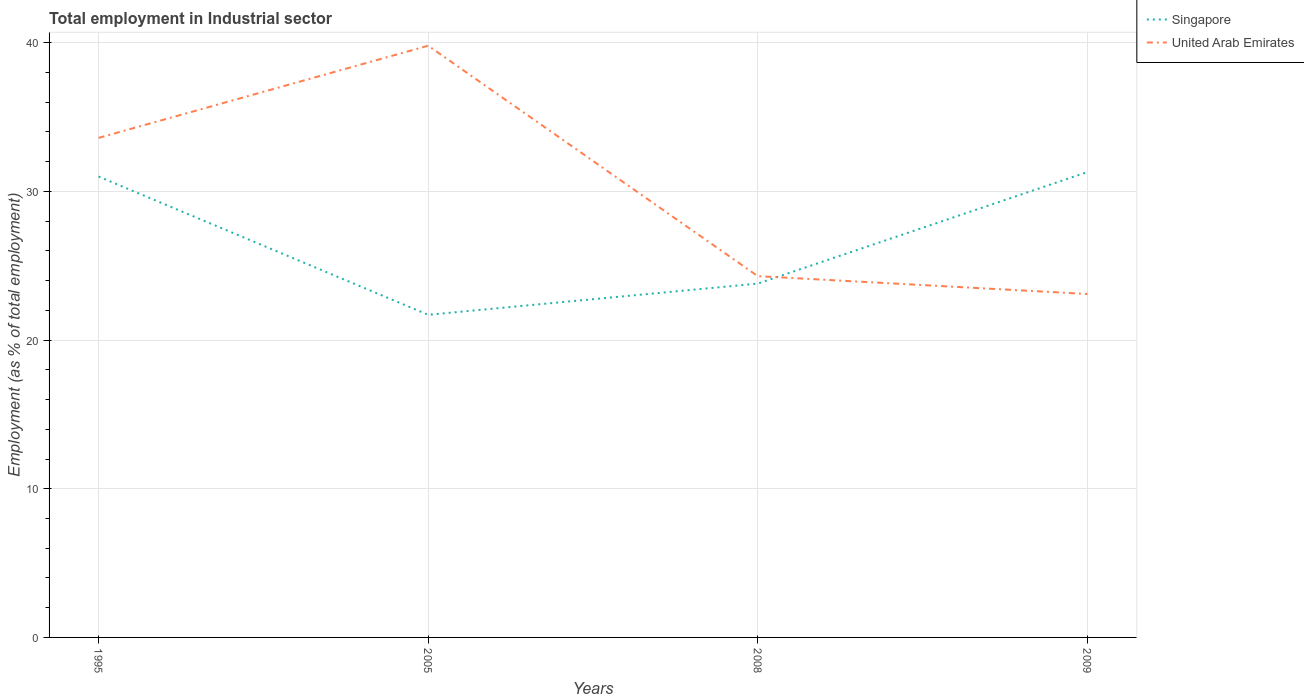Across all years, what is the maximum employment in industrial sector in United Arab Emirates?
Ensure brevity in your answer.  23.1. What is the total employment in industrial sector in United Arab Emirates in the graph?
Provide a succinct answer. 1.2. What is the difference between the highest and the second highest employment in industrial sector in Singapore?
Give a very brief answer. 9.6. What is the difference between the highest and the lowest employment in industrial sector in United Arab Emirates?
Make the answer very short. 2. Is the employment in industrial sector in Singapore strictly greater than the employment in industrial sector in United Arab Emirates over the years?
Provide a short and direct response. No. How many lines are there?
Offer a very short reply. 2. How many years are there in the graph?
Provide a short and direct response. 4. What is the difference between two consecutive major ticks on the Y-axis?
Provide a succinct answer. 10. Are the values on the major ticks of Y-axis written in scientific E-notation?
Your response must be concise. No. How many legend labels are there?
Provide a short and direct response. 2. What is the title of the graph?
Your response must be concise. Total employment in Industrial sector. Does "St. Kitts and Nevis" appear as one of the legend labels in the graph?
Your response must be concise. No. What is the label or title of the X-axis?
Make the answer very short. Years. What is the label or title of the Y-axis?
Your answer should be compact. Employment (as % of total employment). What is the Employment (as % of total employment) in Singapore in 1995?
Offer a terse response. 31. What is the Employment (as % of total employment) in United Arab Emirates in 1995?
Your answer should be compact. 33.6. What is the Employment (as % of total employment) in Singapore in 2005?
Keep it short and to the point. 21.7. What is the Employment (as % of total employment) of United Arab Emirates in 2005?
Keep it short and to the point. 39.8. What is the Employment (as % of total employment) in Singapore in 2008?
Your answer should be very brief. 23.8. What is the Employment (as % of total employment) in United Arab Emirates in 2008?
Keep it short and to the point. 24.3. What is the Employment (as % of total employment) in Singapore in 2009?
Keep it short and to the point. 31.3. What is the Employment (as % of total employment) of United Arab Emirates in 2009?
Your answer should be very brief. 23.1. Across all years, what is the maximum Employment (as % of total employment) in Singapore?
Provide a short and direct response. 31.3. Across all years, what is the maximum Employment (as % of total employment) in United Arab Emirates?
Provide a succinct answer. 39.8. Across all years, what is the minimum Employment (as % of total employment) of Singapore?
Ensure brevity in your answer.  21.7. Across all years, what is the minimum Employment (as % of total employment) of United Arab Emirates?
Provide a short and direct response. 23.1. What is the total Employment (as % of total employment) in Singapore in the graph?
Offer a very short reply. 107.8. What is the total Employment (as % of total employment) of United Arab Emirates in the graph?
Provide a short and direct response. 120.8. What is the difference between the Employment (as % of total employment) in United Arab Emirates in 1995 and that in 2005?
Offer a very short reply. -6.2. What is the difference between the Employment (as % of total employment) of Singapore in 1995 and that in 2008?
Ensure brevity in your answer.  7.2. What is the difference between the Employment (as % of total employment) of United Arab Emirates in 1995 and that in 2008?
Keep it short and to the point. 9.3. What is the difference between the Employment (as % of total employment) of Singapore in 1995 and that in 2009?
Give a very brief answer. -0.3. What is the difference between the Employment (as % of total employment) of Singapore in 2005 and that in 2008?
Offer a very short reply. -2.1. What is the difference between the Employment (as % of total employment) in United Arab Emirates in 2005 and that in 2008?
Your answer should be very brief. 15.5. What is the difference between the Employment (as % of total employment) of United Arab Emirates in 2005 and that in 2009?
Offer a very short reply. 16.7. What is the difference between the Employment (as % of total employment) in Singapore in 1995 and the Employment (as % of total employment) in United Arab Emirates in 2008?
Keep it short and to the point. 6.7. What is the difference between the Employment (as % of total employment) of Singapore in 2005 and the Employment (as % of total employment) of United Arab Emirates in 2009?
Offer a very short reply. -1.4. What is the average Employment (as % of total employment) in Singapore per year?
Keep it short and to the point. 26.95. What is the average Employment (as % of total employment) in United Arab Emirates per year?
Provide a short and direct response. 30.2. In the year 2005, what is the difference between the Employment (as % of total employment) in Singapore and Employment (as % of total employment) in United Arab Emirates?
Give a very brief answer. -18.1. In the year 2009, what is the difference between the Employment (as % of total employment) in Singapore and Employment (as % of total employment) in United Arab Emirates?
Make the answer very short. 8.2. What is the ratio of the Employment (as % of total employment) in Singapore in 1995 to that in 2005?
Provide a short and direct response. 1.43. What is the ratio of the Employment (as % of total employment) of United Arab Emirates in 1995 to that in 2005?
Your response must be concise. 0.84. What is the ratio of the Employment (as % of total employment) of Singapore in 1995 to that in 2008?
Keep it short and to the point. 1.3. What is the ratio of the Employment (as % of total employment) in United Arab Emirates in 1995 to that in 2008?
Your response must be concise. 1.38. What is the ratio of the Employment (as % of total employment) of Singapore in 1995 to that in 2009?
Offer a very short reply. 0.99. What is the ratio of the Employment (as % of total employment) of United Arab Emirates in 1995 to that in 2009?
Your answer should be compact. 1.45. What is the ratio of the Employment (as % of total employment) of Singapore in 2005 to that in 2008?
Provide a succinct answer. 0.91. What is the ratio of the Employment (as % of total employment) in United Arab Emirates in 2005 to that in 2008?
Offer a terse response. 1.64. What is the ratio of the Employment (as % of total employment) in Singapore in 2005 to that in 2009?
Offer a terse response. 0.69. What is the ratio of the Employment (as % of total employment) of United Arab Emirates in 2005 to that in 2009?
Offer a terse response. 1.72. What is the ratio of the Employment (as % of total employment) in Singapore in 2008 to that in 2009?
Ensure brevity in your answer.  0.76. What is the ratio of the Employment (as % of total employment) in United Arab Emirates in 2008 to that in 2009?
Make the answer very short. 1.05. What is the difference between the highest and the second highest Employment (as % of total employment) in Singapore?
Give a very brief answer. 0.3. What is the difference between the highest and the second highest Employment (as % of total employment) in United Arab Emirates?
Your answer should be very brief. 6.2. What is the difference between the highest and the lowest Employment (as % of total employment) in Singapore?
Offer a terse response. 9.6. 